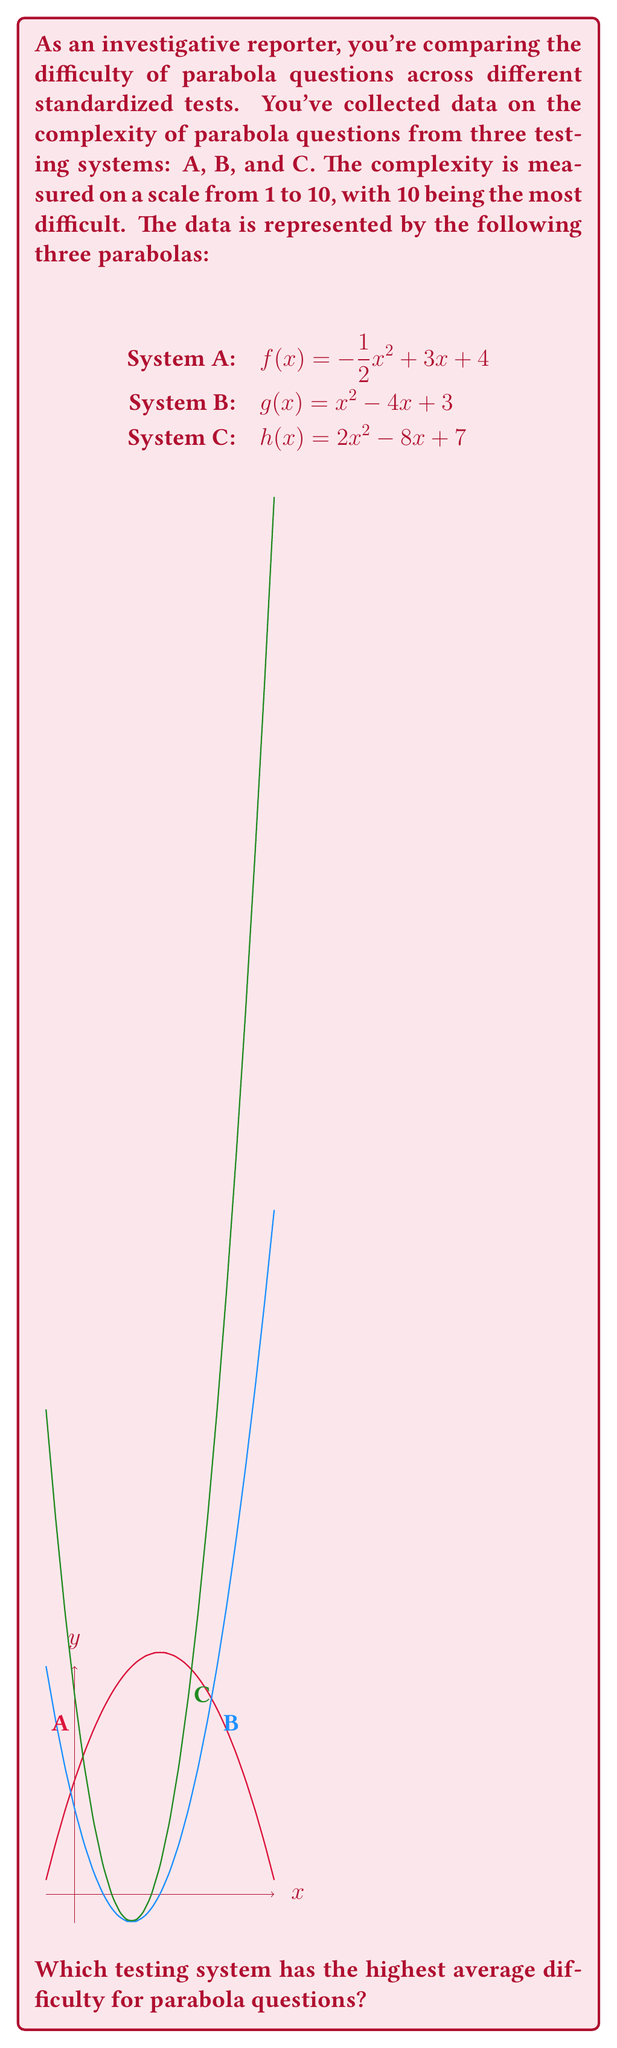What is the answer to this math problem? To determine which testing system has the highest average difficulty, we need to find the maximum value of each parabola, as this represents the peak complexity of questions in each system.

1) For System A: $f(x) = -\frac{1}{2}x^2 + 3x + 4$
   The axis of symmetry is given by $x = -\frac{b}{2a} = -\frac{3}{2(-\frac{1}{2})} = 3$
   The maximum value is $f(3) = -\frac{1}{2}(3)^2 + 3(3) + 4 = 8.5$

2) For System B: $g(x) = x^2 - 4x + 3$
   The axis of symmetry is $x = -\frac{b}{2a} = -\frac{-4}{2(1)} = 2$
   The maximum value is $g(2) = (2)^2 - 4(2) + 3 = -1$

3) For System C: $h(x) = 2x^2 - 8x + 7$
   The axis of symmetry is $x = -\frac{b}{2a} = -\frac{-8}{2(2)} = 2$
   The maximum value is $h(2) = 2(2)^2 - 8(2) + 7 = -1$

The highest maximum value is 8.5, corresponding to System A.
Answer: System A 